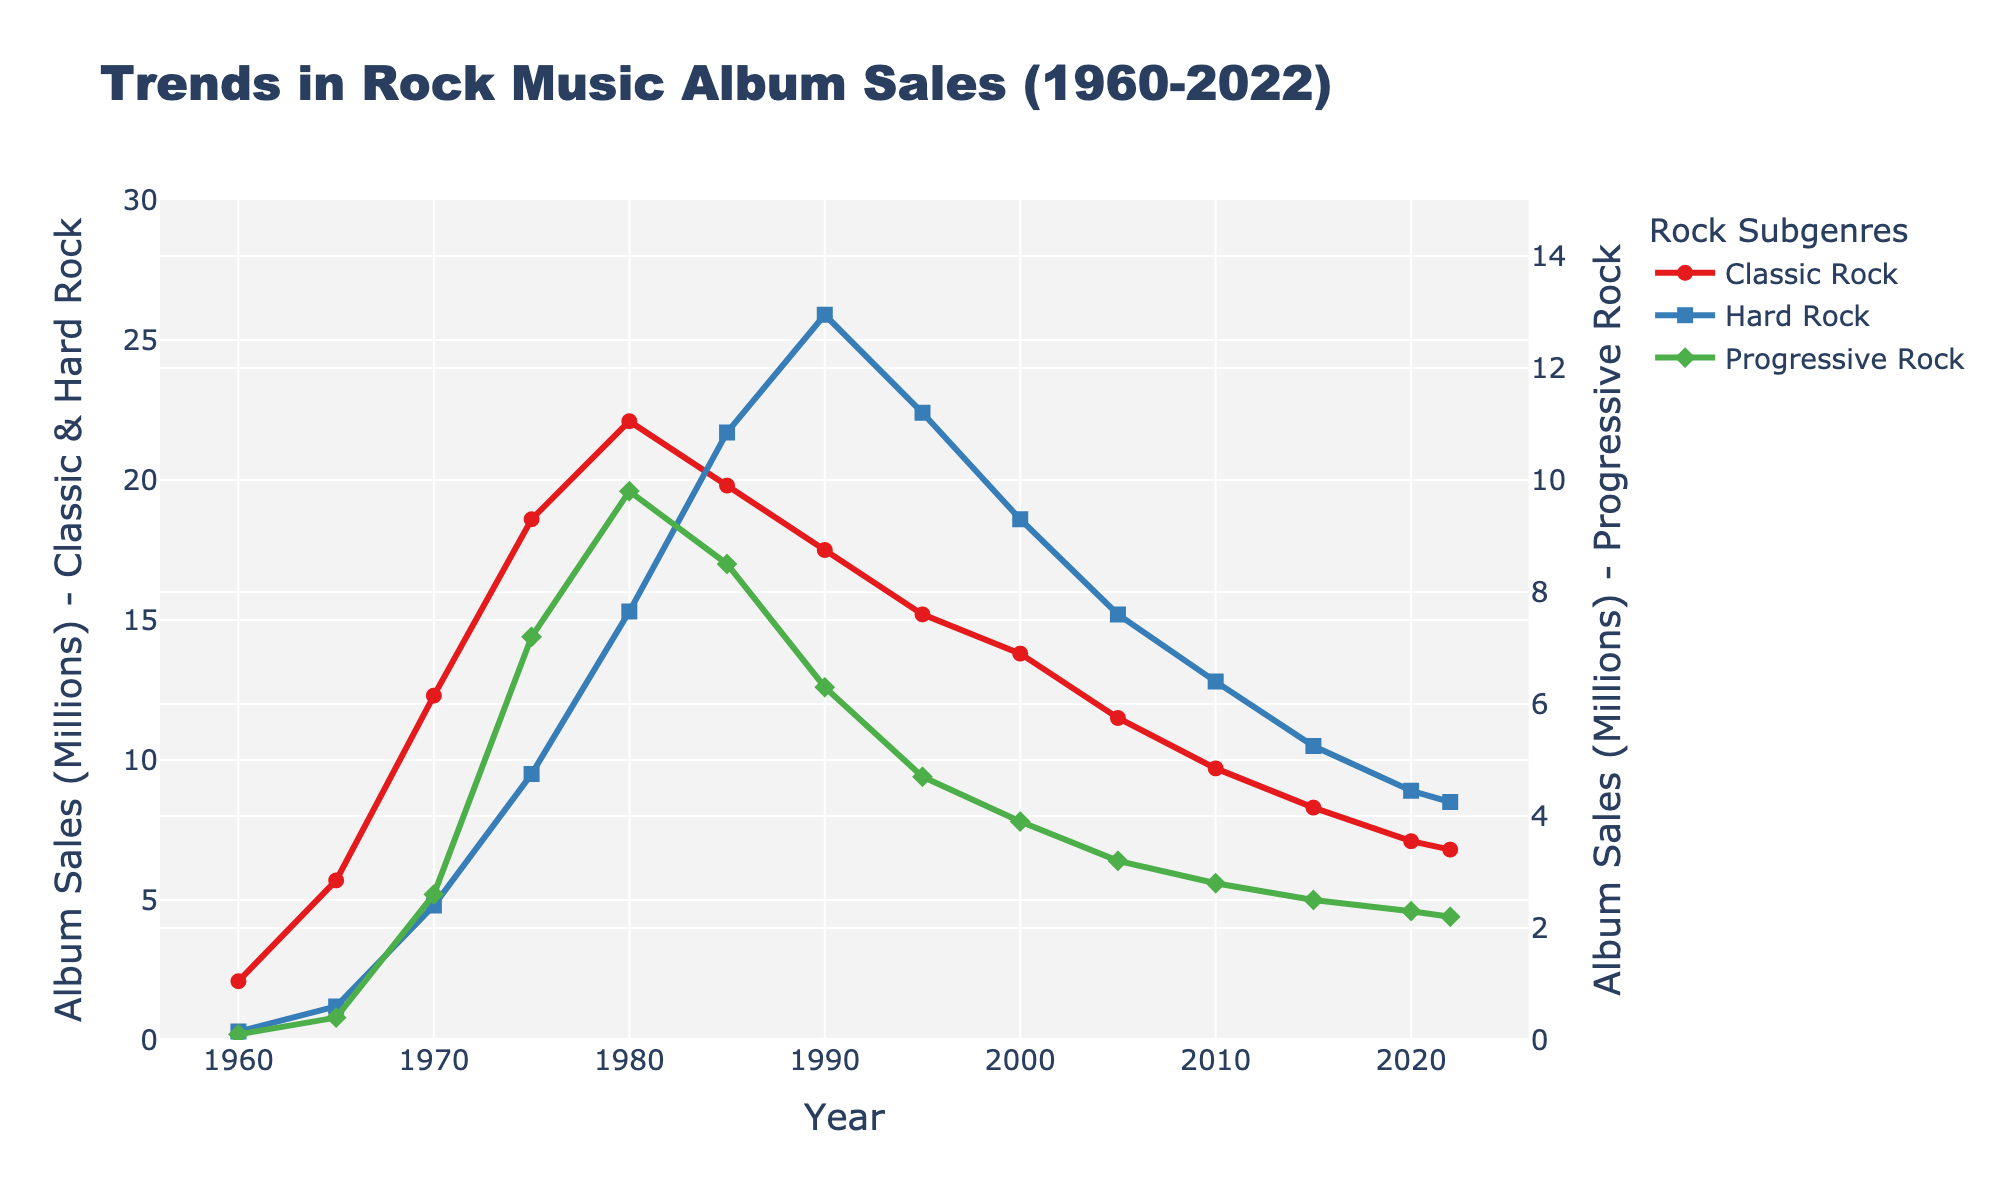What is the highest album sales value for Progressive Rock? Observe the peak of the green line representing Progressive Rock and check its corresponding value on the y-axis, which is around the year 1980.
Answer: 9.8 million Which subgenre had the highest sales in 1985? Look at the values for each subgenre in the year 1985. Hard Rock peaks at 21.7 million, which is higher than both Classic Rock and Progressive Rock.
Answer: Hard Rock Compare the sales of Classic Rock and Hard Rock in 1990. Which was higher and by how much? Classic Rock sales in 1990 were 17.5 million, and Hard Rock sales were 25.9 million. The difference is 25.9 - 17.5 = 8.4 million, and Hard Rock was higher.
Answer: Hard Rock by 8.4 million Between 1960 and 1980, in which subgenre did album sales grow the most? Calculate the growth for each subgenre:
Classic Rock: 22.1 - 2.1 = 20 million,
Hard Rock: 15.3 - 0.3 = 15 million,
Progressive Rock: 9.8 - 0.1 = 9.7 million.
Classic Rock grew the most.
Answer: Classic Rock by 20 million What is the trend for Hard Rock album sales from 2000 to 2020? Observe the blue line from the year 2000 to 2020. It shows a decreasing trend from 18.6 million in 2000 to 8.9 million in 2020.
Answer: Decreasing Which year saw the highest album sales for Classic Rock? Identify the peak of the red line representing Classic Rock. The highest value is at the year 1980.
Answer: 1980 Calculate the average sales for Progressive Rock over the entire period. Sum the sales values of Progressive Rock for all years and divide by the number of years.
Sum = 0.1 + 0.4 + 2.6 + 7.2 + 9.8 + 8.5 + 6.3 + 4.7 + 3.9 + 3.2 + 2.8 + 2.5 + 2.3 + 2.2 = 56.5
Number of years = 14
Average = 56.5 / 14 ≈ 4.04 million
Answer: 4.04 million Compare the visual patterns of Classic Rock and Progressive Rock between 1970 and 2000. What do you observe? Examine the red and green lines between 1970 and 2000. Classic Rock line shows a peak around 1980 and then declines gradually. Progressive Rock shows a rise until 1980, then a steep fall.
Answer: Classic Rock: peak and gradual decline, Progressive Rock: rise then steep fall 